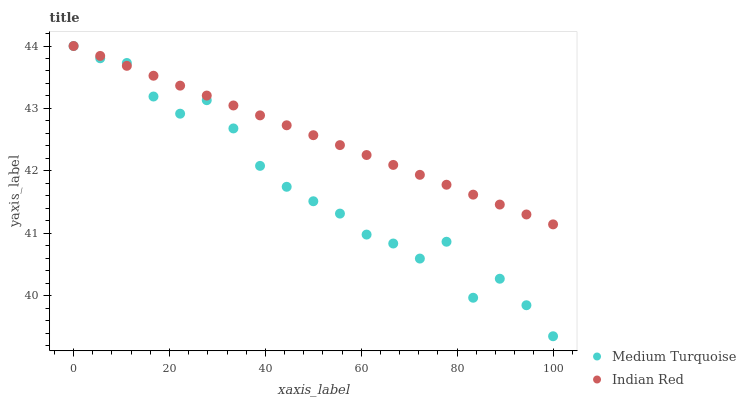Does Medium Turquoise have the minimum area under the curve?
Answer yes or no. Yes. Does Indian Red have the maximum area under the curve?
Answer yes or no. Yes. Does Medium Turquoise have the maximum area under the curve?
Answer yes or no. No. Is Indian Red the smoothest?
Answer yes or no. Yes. Is Medium Turquoise the roughest?
Answer yes or no. Yes. Is Medium Turquoise the smoothest?
Answer yes or no. No. Does Medium Turquoise have the lowest value?
Answer yes or no. Yes. Does Medium Turquoise have the highest value?
Answer yes or no. Yes. Does Indian Red intersect Medium Turquoise?
Answer yes or no. Yes. Is Indian Red less than Medium Turquoise?
Answer yes or no. No. Is Indian Red greater than Medium Turquoise?
Answer yes or no. No. 